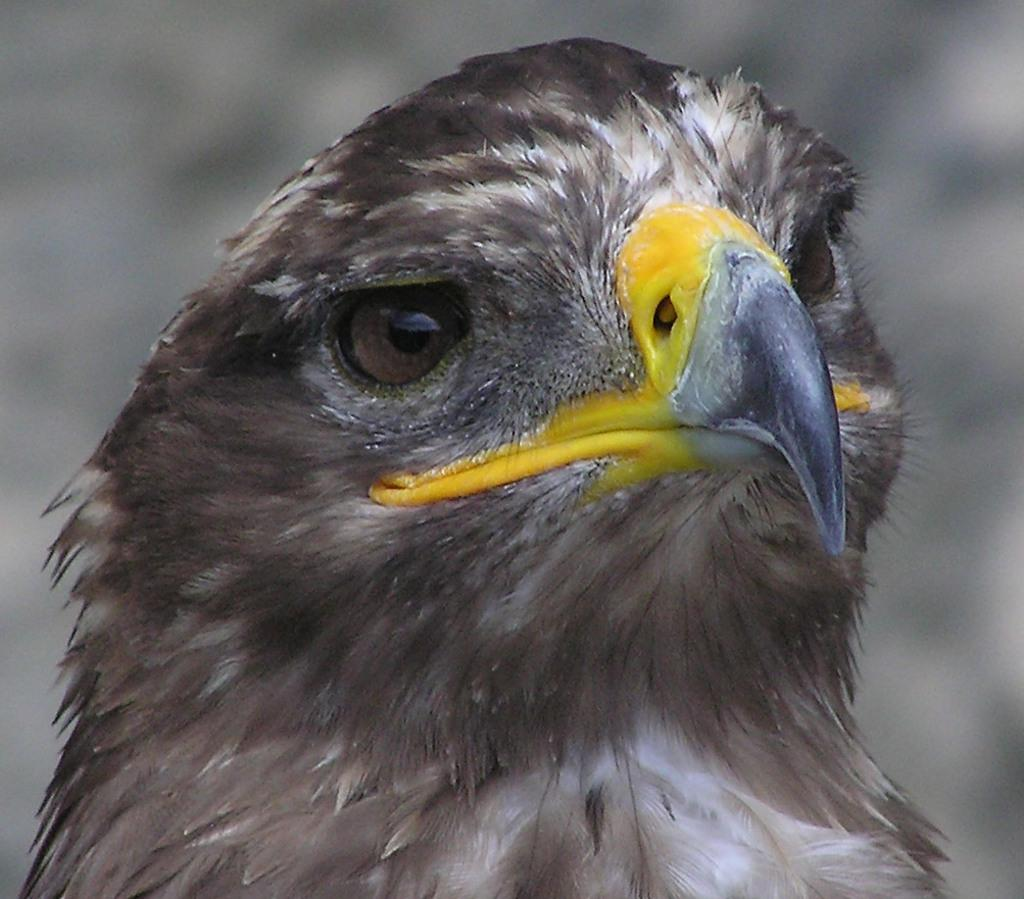What type of animal can be seen in the image? There is a bird in the image. What type of gun is the bird holding in the image? There is no gun present in the image; it features a bird. 